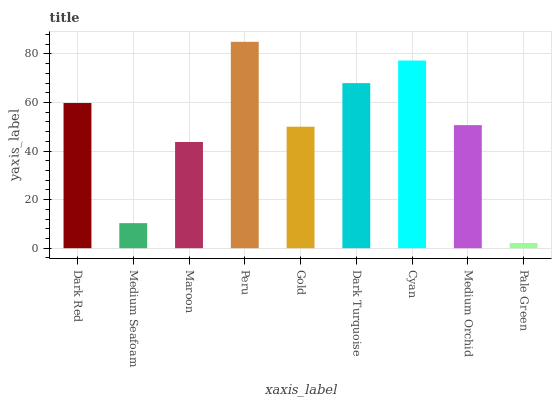Is Pale Green the minimum?
Answer yes or no. Yes. Is Peru the maximum?
Answer yes or no. Yes. Is Medium Seafoam the minimum?
Answer yes or no. No. Is Medium Seafoam the maximum?
Answer yes or no. No. Is Dark Red greater than Medium Seafoam?
Answer yes or no. Yes. Is Medium Seafoam less than Dark Red?
Answer yes or no. Yes. Is Medium Seafoam greater than Dark Red?
Answer yes or no. No. Is Dark Red less than Medium Seafoam?
Answer yes or no. No. Is Medium Orchid the high median?
Answer yes or no. Yes. Is Medium Orchid the low median?
Answer yes or no. Yes. Is Maroon the high median?
Answer yes or no. No. Is Gold the low median?
Answer yes or no. No. 